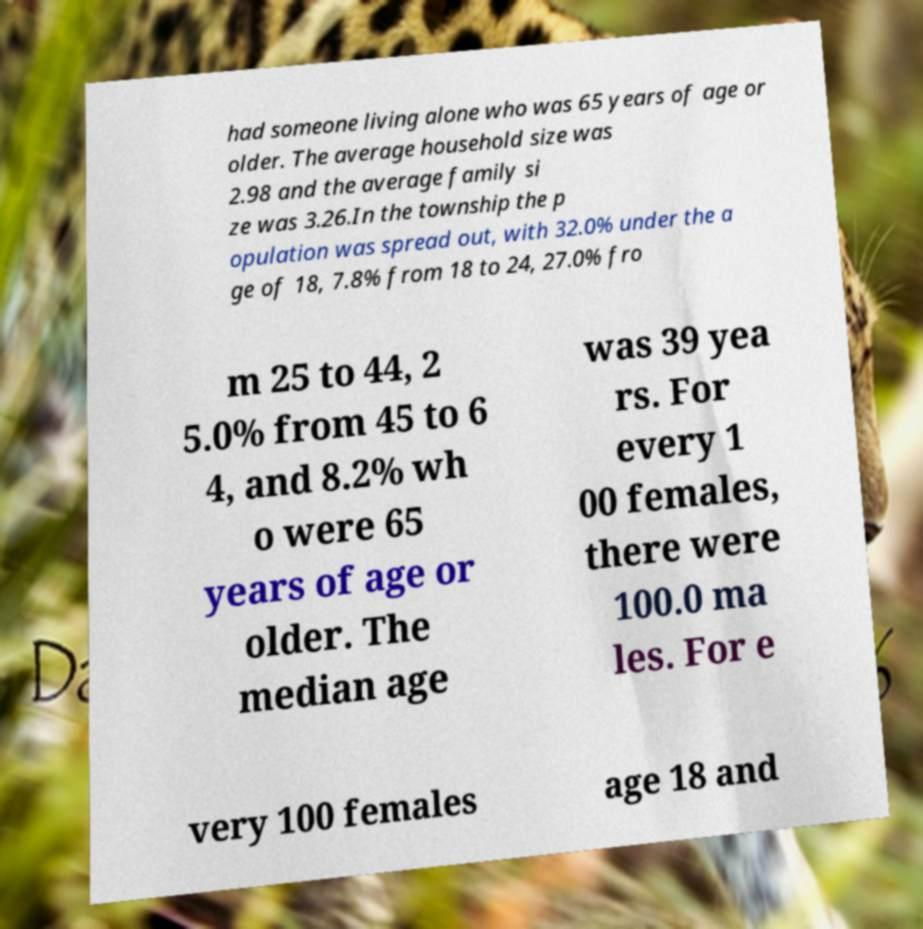What messages or text are displayed in this image? I need them in a readable, typed format. had someone living alone who was 65 years of age or older. The average household size was 2.98 and the average family si ze was 3.26.In the township the p opulation was spread out, with 32.0% under the a ge of 18, 7.8% from 18 to 24, 27.0% fro m 25 to 44, 2 5.0% from 45 to 6 4, and 8.2% wh o were 65 years of age or older. The median age was 39 yea rs. For every 1 00 females, there were 100.0 ma les. For e very 100 females age 18 and 